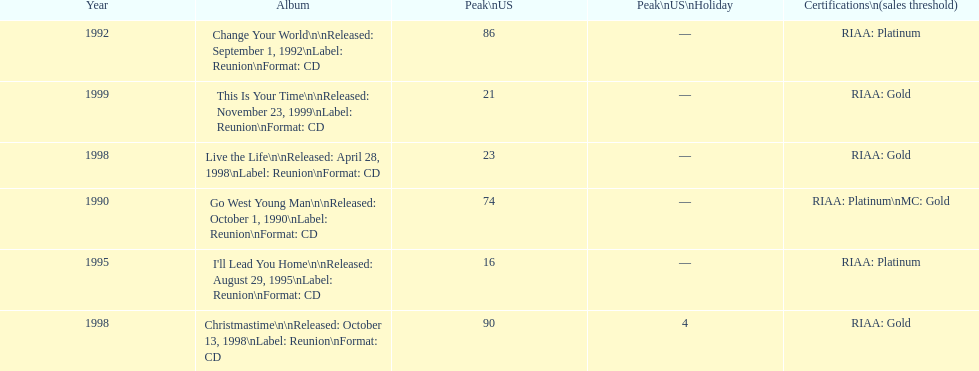Riaa: gold is only one of the certifications, but what is the other? Platinum. 